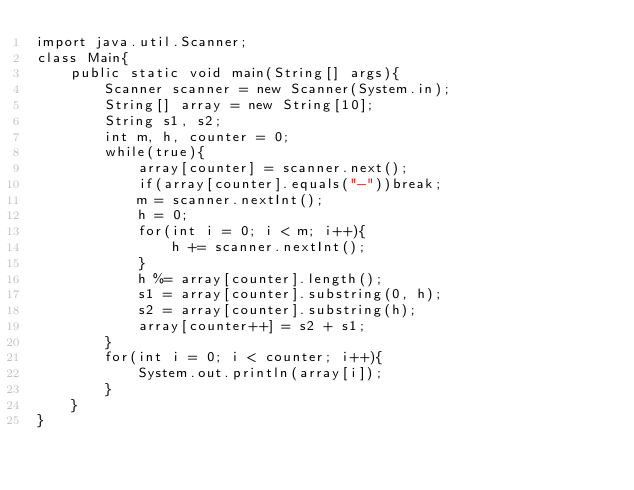Convert code to text. <code><loc_0><loc_0><loc_500><loc_500><_Java_>import java.util.Scanner;
class Main{
    public static void main(String[] args){
        Scanner scanner = new Scanner(System.in);
        String[] array = new String[10];
        String s1, s2;
        int m, h, counter = 0;
        while(true){
            array[counter] = scanner.next();
            if(array[counter].equals("-"))break;
            m = scanner.nextInt();
            h = 0;
            for(int i = 0; i < m; i++){
                h += scanner.nextInt();
            }
            h %= array[counter].length();
            s1 = array[counter].substring(0, h);
            s2 = array[counter].substring(h);
            array[counter++] = s2 + s1;
        }
        for(int i = 0; i < counter; i++){
            System.out.println(array[i]);
        }
    }
}

</code> 